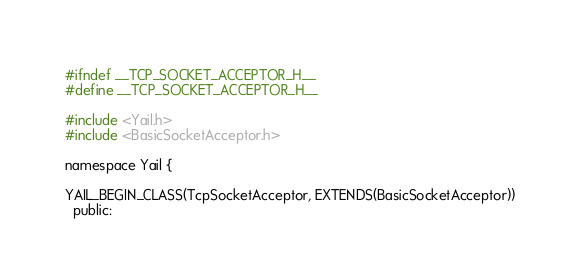Convert code to text. <code><loc_0><loc_0><loc_500><loc_500><_C_>#ifndef __TCP_SOCKET_ACCEPTOR_H__
#define __TCP_SOCKET_ACCEPTOR_H__

#include <Yail.h>
#include <BasicSocketAcceptor.h>

namespace Yail {

YAIL_BEGIN_CLASS(TcpSocketAcceptor, EXTENDS(BasicSocketAcceptor))
  public:</code> 